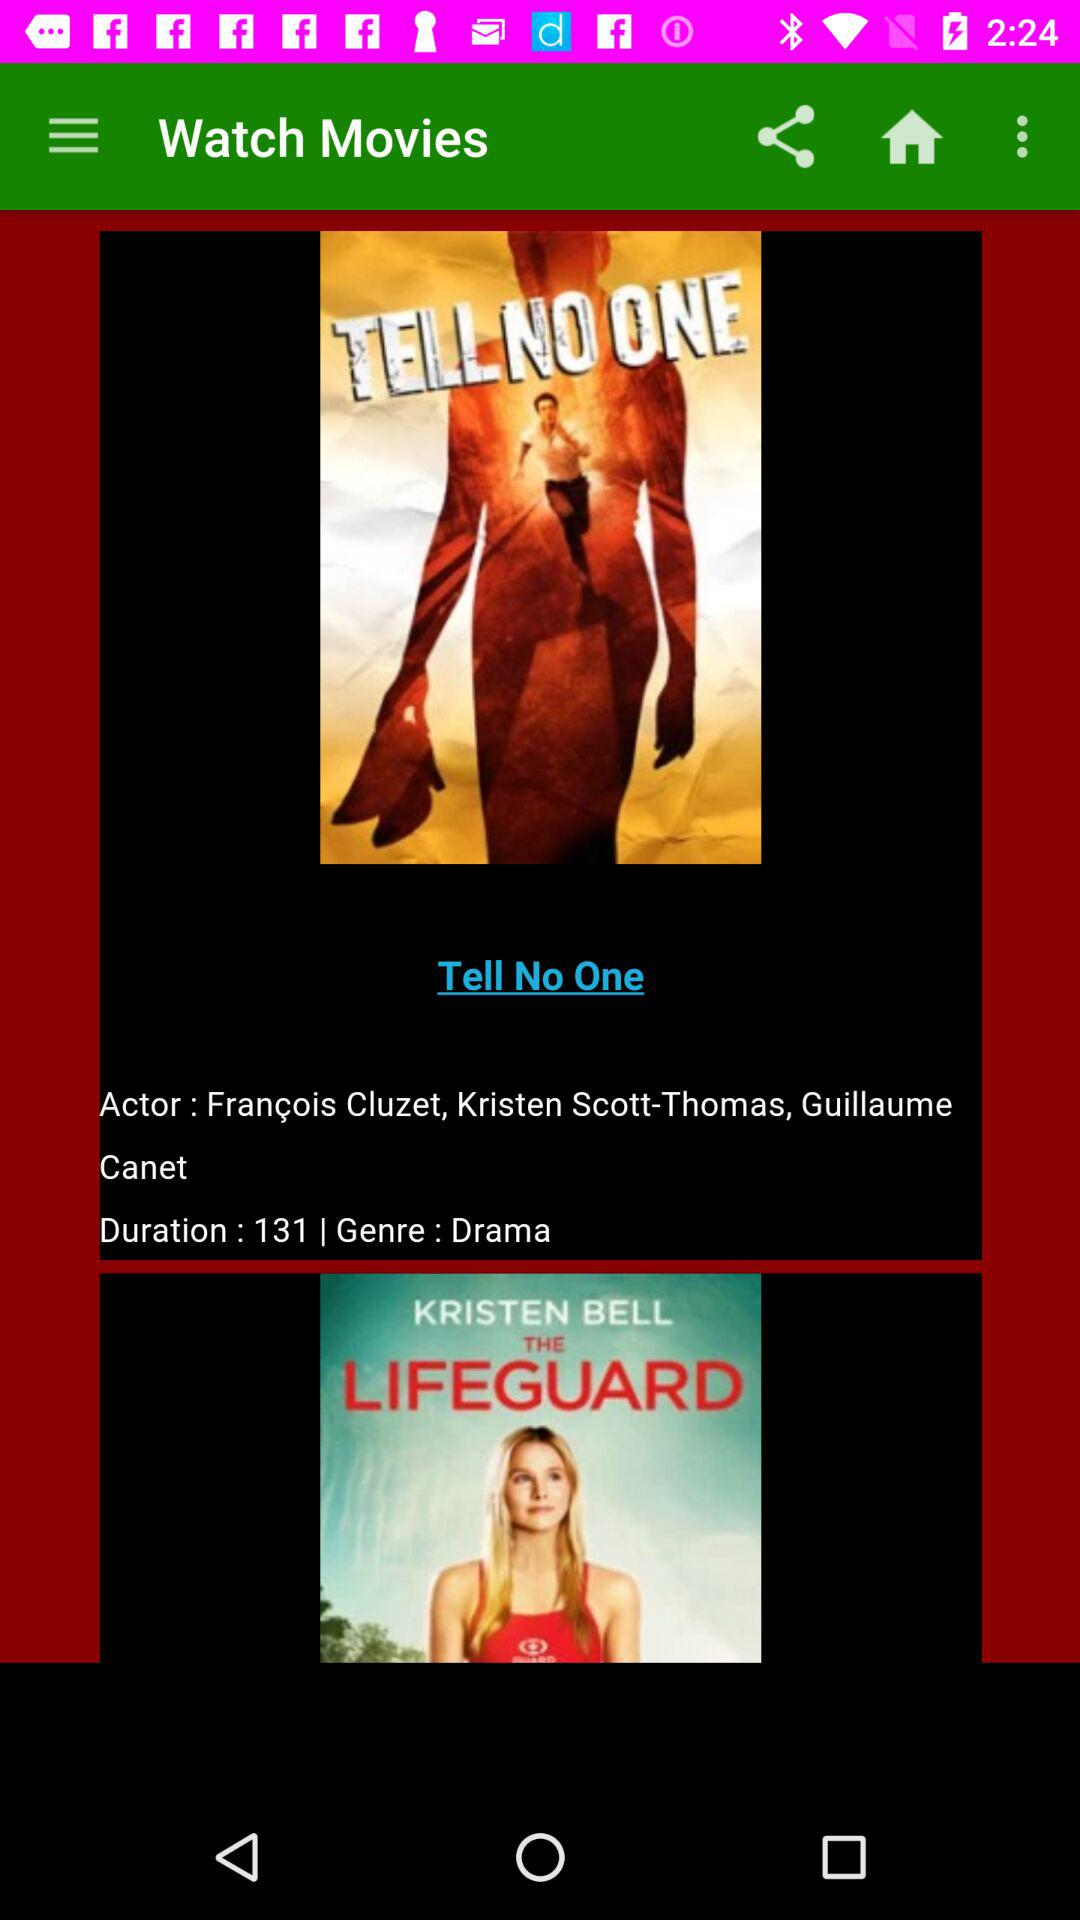What is the genre type of movie? The genre type of movie is drama. 